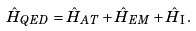Convert formula to latex. <formula><loc_0><loc_0><loc_500><loc_500>\hat { H } _ { Q E D } = \hat { H } _ { A T } + \hat { H } _ { E M } + \hat { H } _ { \mathrm I } \, .</formula> 